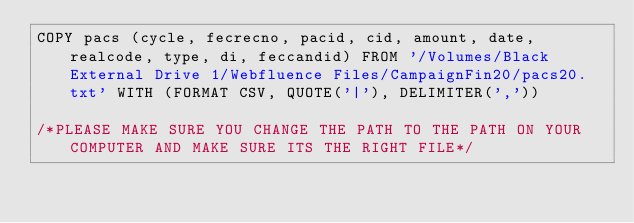Convert code to text. <code><loc_0><loc_0><loc_500><loc_500><_SQL_>COPY pacs (cycle, fecrecno, pacid, cid, amount, date, realcode, type, di, feccandid) FROM '/Volumes/Black External Drive 1/Webfluence Files/CampaignFin20/pacs20.txt' WITH (FORMAT CSV, QUOTE('|'), DELIMITER(','))

/*PLEASE MAKE SURE YOU CHANGE THE PATH TO THE PATH ON YOUR COMPUTER AND MAKE SURE ITS THE RIGHT FILE*/
</code> 